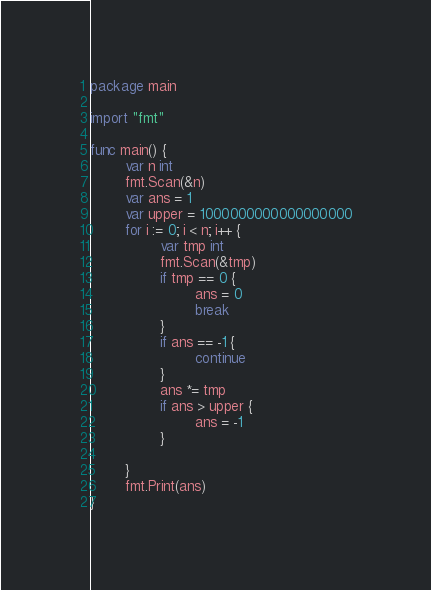<code> <loc_0><loc_0><loc_500><loc_500><_Go_>package main

import "fmt"

func main() {
        var n int
        fmt.Scan(&n)
        var ans = 1
        var upper = 1000000000000000000
        for i := 0; i < n; i++ {
                var tmp int
                fmt.Scan(&tmp)
                if tmp == 0 {
                        ans = 0
                        break
                }
                if ans == -1 {
                        continue
                }
                ans *= tmp
                if ans > upper {
                        ans = -1
                }

        }
        fmt.Print(ans)
}</code> 